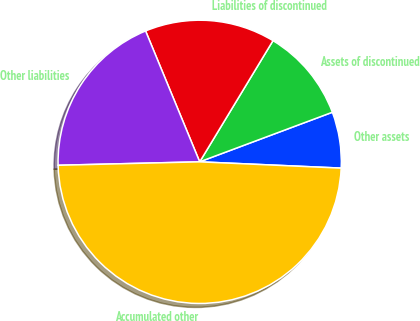Convert chart to OTSL. <chart><loc_0><loc_0><loc_500><loc_500><pie_chart><fcel>Other assets<fcel>Assets of discontinued<fcel>Liabilities of discontinued<fcel>Other liabilities<fcel>Accumulated other<nl><fcel>6.4%<fcel>10.65%<fcel>14.9%<fcel>19.15%<fcel>48.91%<nl></chart> 